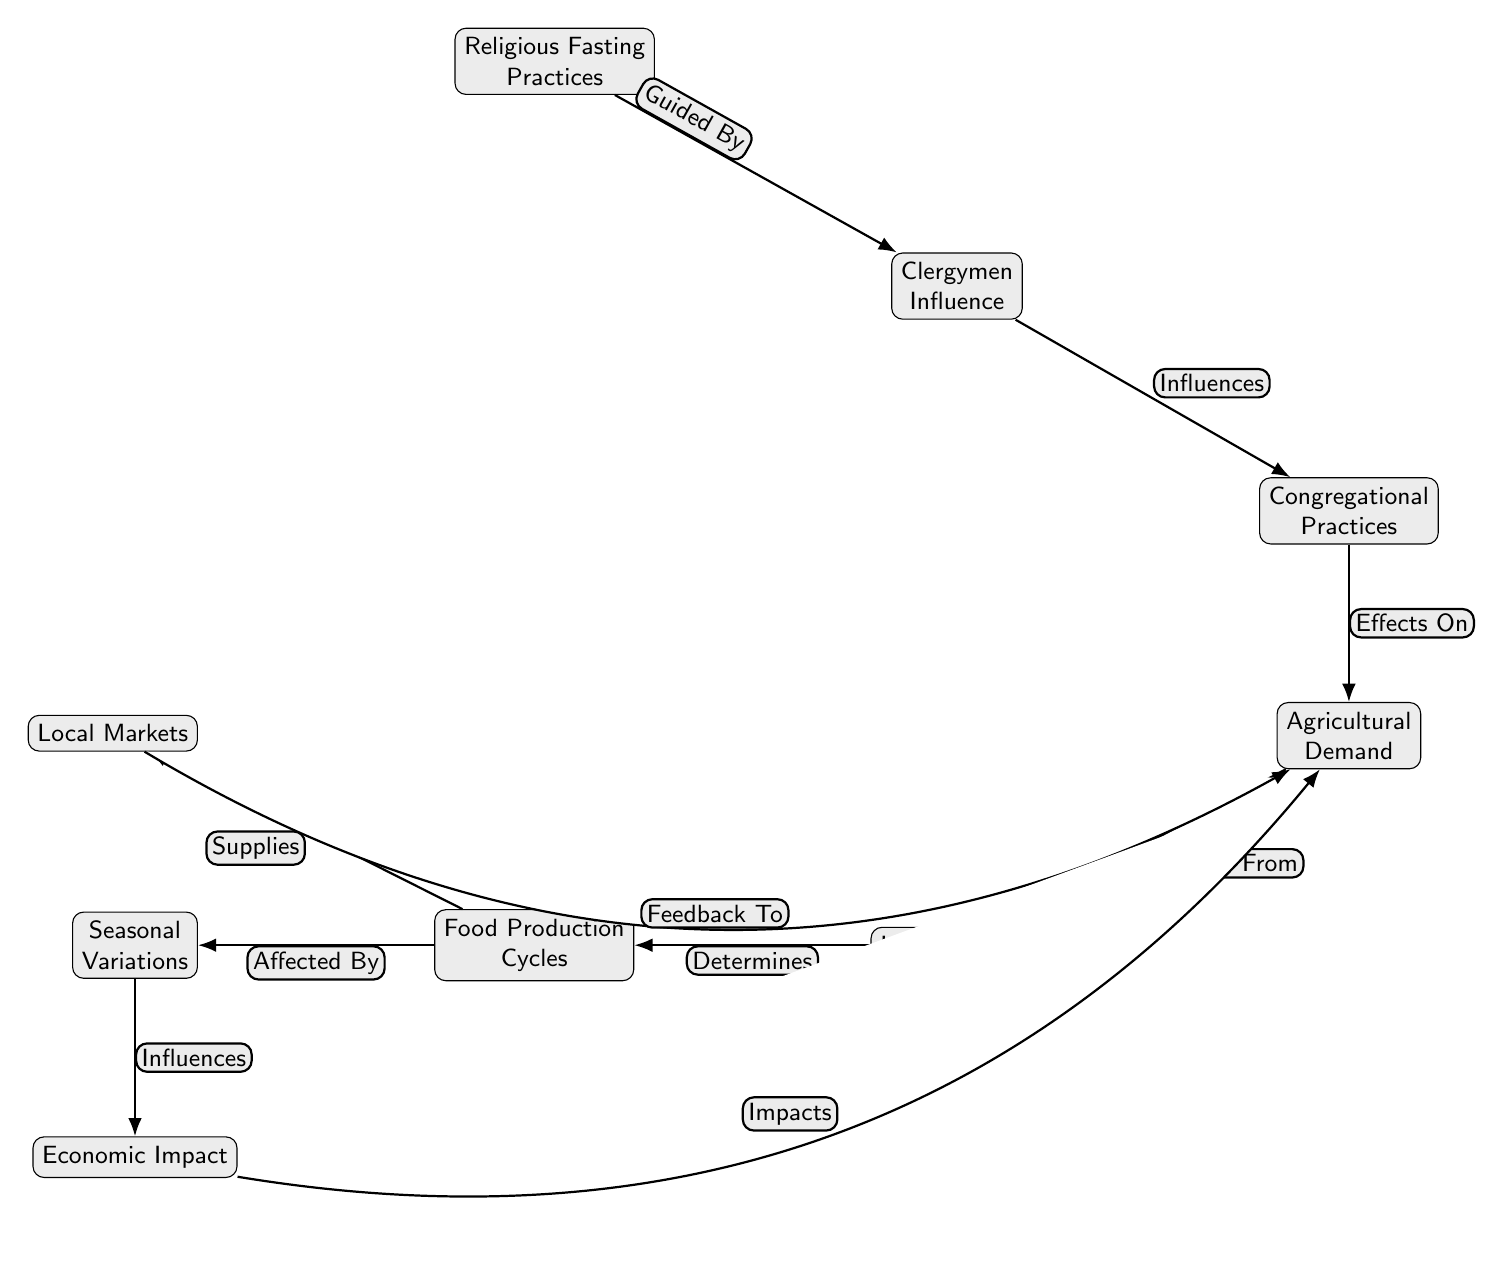What is the primary focus of the diagram? The diagram primarily focuses on the relationships and influences between religious fasting practices and agricultural demand. This is evident from the key node labeled "Religious Fasting Practices" at the top, indicating it's the starting point of the flow.
Answer: Religious Fasting Practices How many main nodes are in the diagram? By counting the labeled nodes in the diagram, we find there are a total of nine nodes, each representing a distinct concept or component related to the food chain.
Answer: 9 What connects "Clergymen Influence" to "Agricultural Demand"? The edge labeled "Effects On" connects "Clergymen Influence" to "Agricultural Demand," showing the direct relationship between clergy's influence on congregational practices and the resulting agricultural demand.
Answer: Effects On Which node determines the "Food Production Cycles"? The node "Local Farmers" directly determines the "Food Production Cycles," as indicated by the edge labeled "Determines" that connects them in the diagram.
Answer: Local Farmers What is the relationship between "Local Markets" and "Agricultural Demand"? There is a feedback relationship shown by the edge bent back from "Local Markets" to "Agricultural Demand," labeled "Feedback To," indicating that local markets influence the demand for agricultural products as they supply them.
Answer: Feedback To How does "Seasonal Variations" interact with "Economic Impact"? "Seasonal Variations" interacts with "Economic Impact" by influencing it as specified by the edge labeled "Influences." This indicates that changes in seasons affect economic conditions and these variations shape economic outcomes.
Answer: Influences What is the "Economic Impact" on in the diagram? The "Economic Impact" is shown to impact "Agricultural Demand," as indicated by the bent edge labeled "Impacts," prompting changes in demand based on economic conditions.
Answer: Impacts Which node is affected by "Food Production Cycles"? "Local Markets" is the node affected by "Food Production Cycles," as the edge labeled "Supplies" indicates that food production directly supplies local market demands.
Answer: Local Markets What type of influence does "Clergymen Influence" have on "Congregational Practices"? The influence is labeled as "Influences," indicating that clergymen's actions and guidance affect how congregations practice fasting and dietary choices.
Answer: Influences 